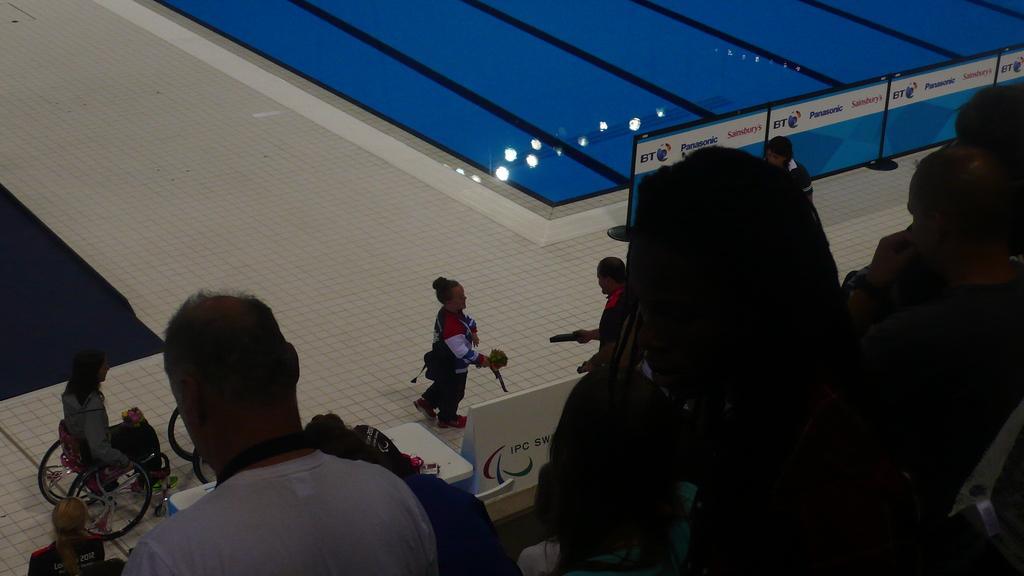Describe this image in one or two sentences. Here in this picture in the middle we can see a woman walking on the floor over there and behind her we can see another woman on a wheelchair present over there and the woman in the front is receiving something from the person standing in front of her over there and we can see some banners present and we can also see a pool, which is filled with water over there and in the front we can see present over there and in the water we can see reflections of light present over there. 